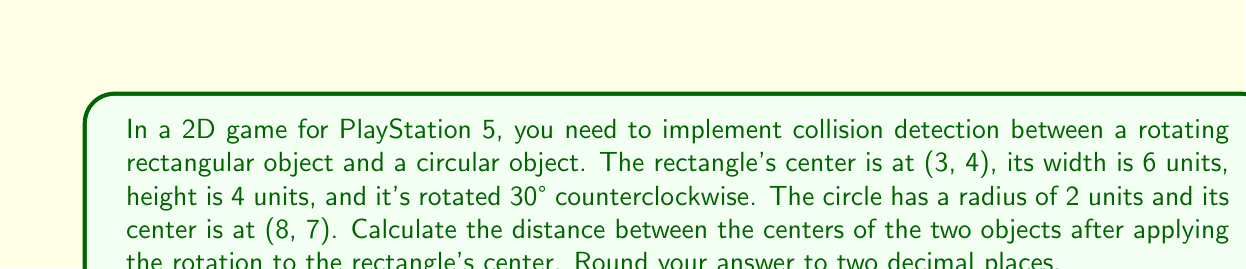Can you answer this question? To solve this problem, we'll follow these steps:

1) First, we need to understand that the rotation doesn't affect the position of the rectangle's center. It only affects the orientation of the rectangle itself.

2) The centers of the two objects are given:
   Rectangle center: (3, 4)
   Circle center: (8, 7)

3) To find the distance between these two points, we can use the distance formula:

   $$d = \sqrt{(x_2 - x_1)^2 + (y_2 - y_1)^2}$$

   Where $(x_1, y_1)$ is the rectangle's center and $(x_2, y_2)$ is the circle's center.

4) Plugging in the values:

   $$d = \sqrt{(8 - 3)^2 + (7 - 4)^2}$$

5) Simplify:

   $$d = \sqrt{5^2 + 3^2}$$
   $$d = \sqrt{25 + 9}$$
   $$d = \sqrt{34}$$

6) Calculate and round to two decimal places:

   $$d \approx 5.83$$

Note: The rotation of the rectangle doesn't affect this calculation because we're only concerned with the distance between the centers. However, for actual collision detection, you would need to consider the rotation when checking if the objects intersect.
Answer: 5.83 units 